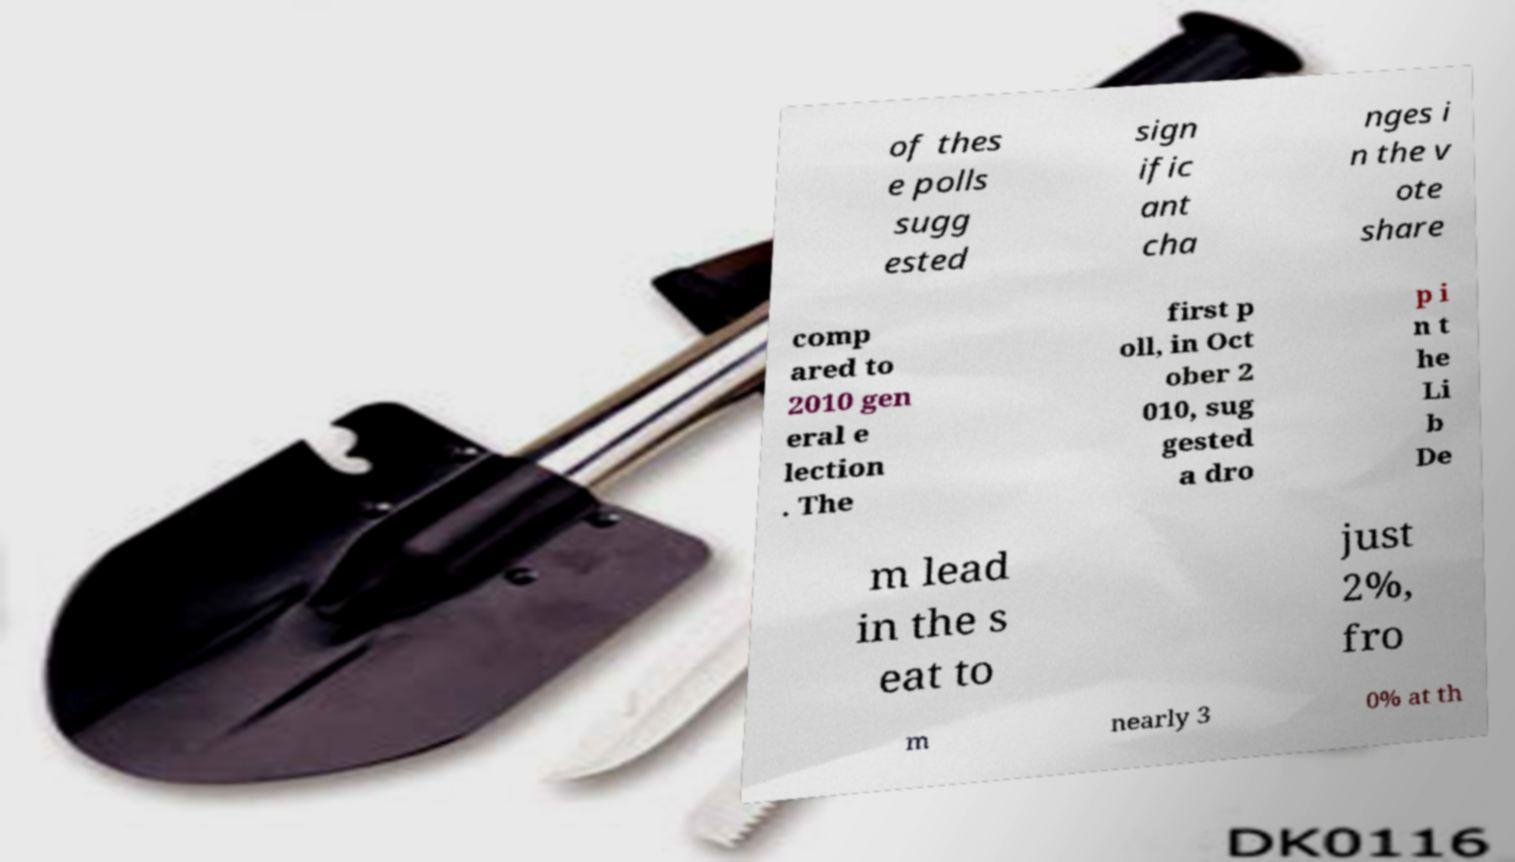Please identify and transcribe the text found in this image. of thes e polls sugg ested sign ific ant cha nges i n the v ote share comp ared to 2010 gen eral e lection . The first p oll, in Oct ober 2 010, sug gested a dro p i n t he Li b De m lead in the s eat to just 2%, fro m nearly 3 0% at th 